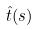Convert formula to latex. <formula><loc_0><loc_0><loc_500><loc_500>\hat { t } ( s )</formula> 